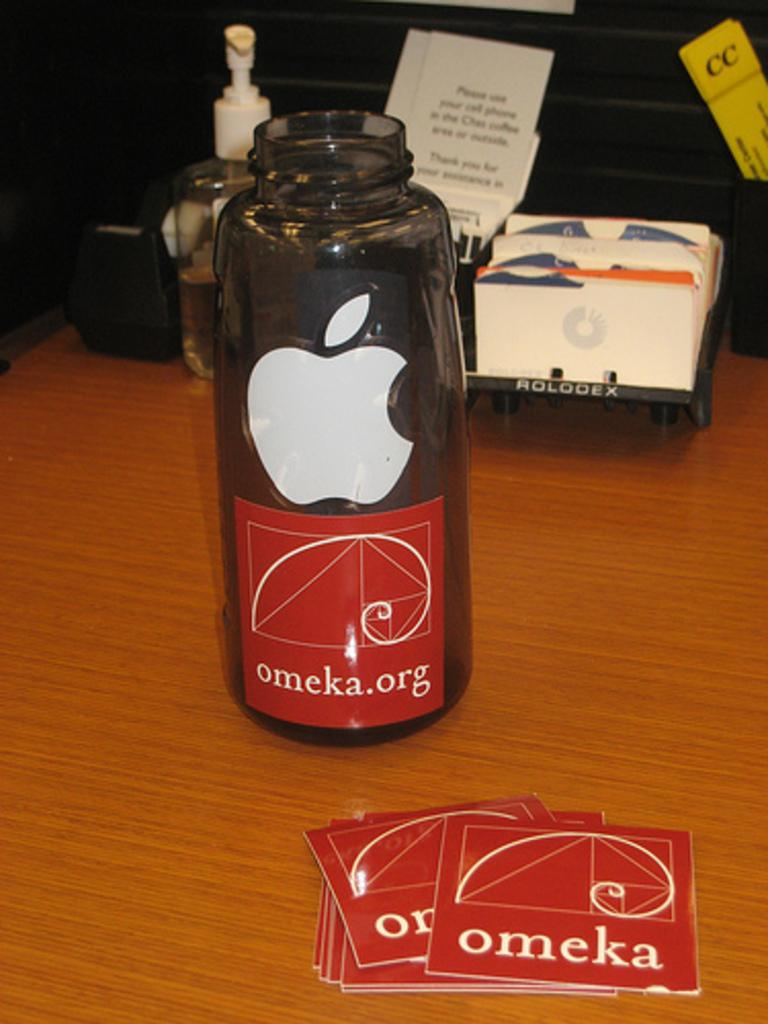What type of furniture is visible in the image? There is a table in the image. What is placed on the table? Cards, a bottle, and a paper are present on the table. Are there any other items on the table? Yes, there are other items on the table. What type of canvas is visible in the image? There is no canvas present in the image. How does the town look in the image? There is no town present in the image. 